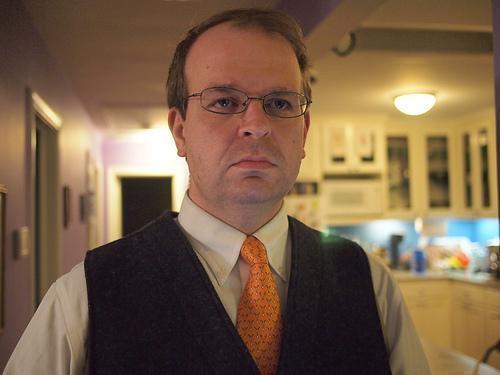How many people are in the picture?
Give a very brief answer. 1. 